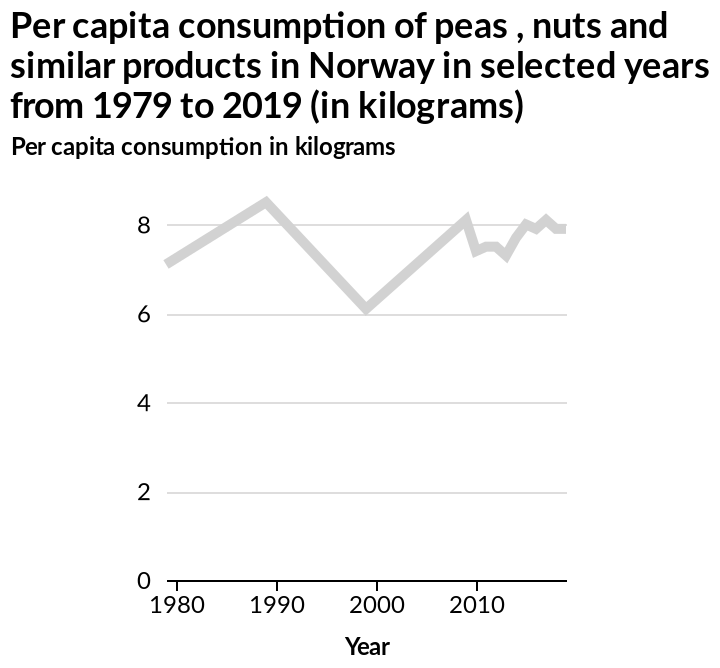<image>
What is the range of the amount consumed per Capita between the years shown?  The range is between 6 and 9 kg. please summary the statistics and relations of the chart In the years shown, the amount consumed has remained between 6 and 9 kg per Capita. The amount has risen and fallen with seemingly no set pattern. In 2000, only 6kg were consumed whereas in 1990, this was over 8kg. What is the range of the x-axis in the line plot?  The range of the x-axis is from 1980 to 2010. What is the range of the y-axis in the line plot?  The range of the y-axis is from 0 to 8 kilograms. Has there been an overall increase or decrease in the amount consumed per Capita between the years shown? Based on the given information, it is not clear whether there has been an overall increase or decrease. 